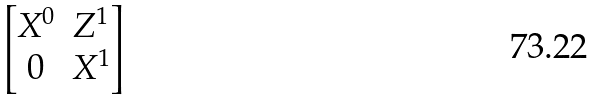<formula> <loc_0><loc_0><loc_500><loc_500>\begin{bmatrix} X ^ { 0 } & Z ^ { 1 } \\ 0 & X ^ { 1 } \end{bmatrix}</formula> 